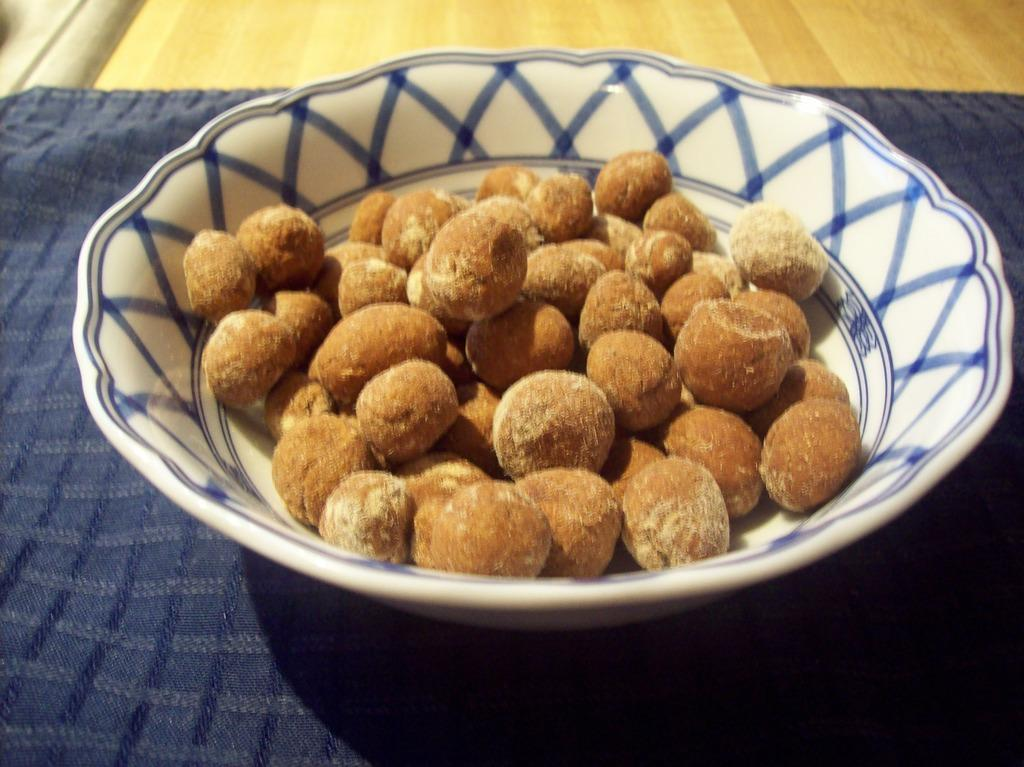What type of table is in the image? There is a wooden table in the image. Is there anything on top of the table? Yes, there is a cloth on the table. What else can be seen on the table? There is a bowl on the table. What is inside the bowl? The bowl contains food items. Are there any pets visible in the image? No, there are no pets present in the image. Can you tell me how many people have expressed a desire for the food items in the image? There is no information about people's desires in the image; it only shows a wooden table with a cloth, a bowl, and food items. 